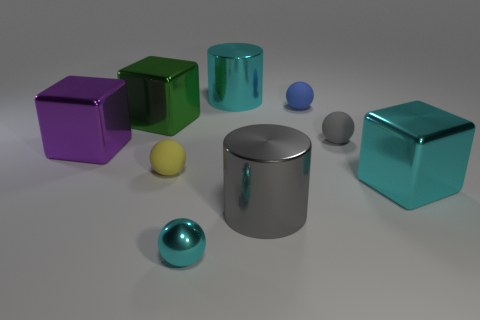Is the number of large cubes that are behind the green metal block less than the number of large cubes that are on the left side of the small shiny object?
Make the answer very short. Yes. What number of other objects are there of the same shape as the green shiny object?
Keep it short and to the point. 2. Is the number of large cubes that are left of the tiny gray rubber thing less than the number of big purple objects?
Your response must be concise. No. What material is the thing that is to the right of the gray matte thing?
Offer a very short reply. Metal. What number of other objects are the same size as the blue matte sphere?
Provide a succinct answer. 3. Are there fewer tiny green rubber cylinders than green blocks?
Offer a very short reply. Yes. What shape is the tiny blue matte object?
Your answer should be very brief. Sphere. Is the color of the big cylinder that is behind the small gray matte object the same as the shiny ball?
Your answer should be very brief. Yes. What is the shape of the shiny thing that is in front of the big cyan block and behind the tiny shiny thing?
Provide a short and direct response. Cylinder. What color is the block on the right side of the big green thing?
Ensure brevity in your answer.  Cyan. 